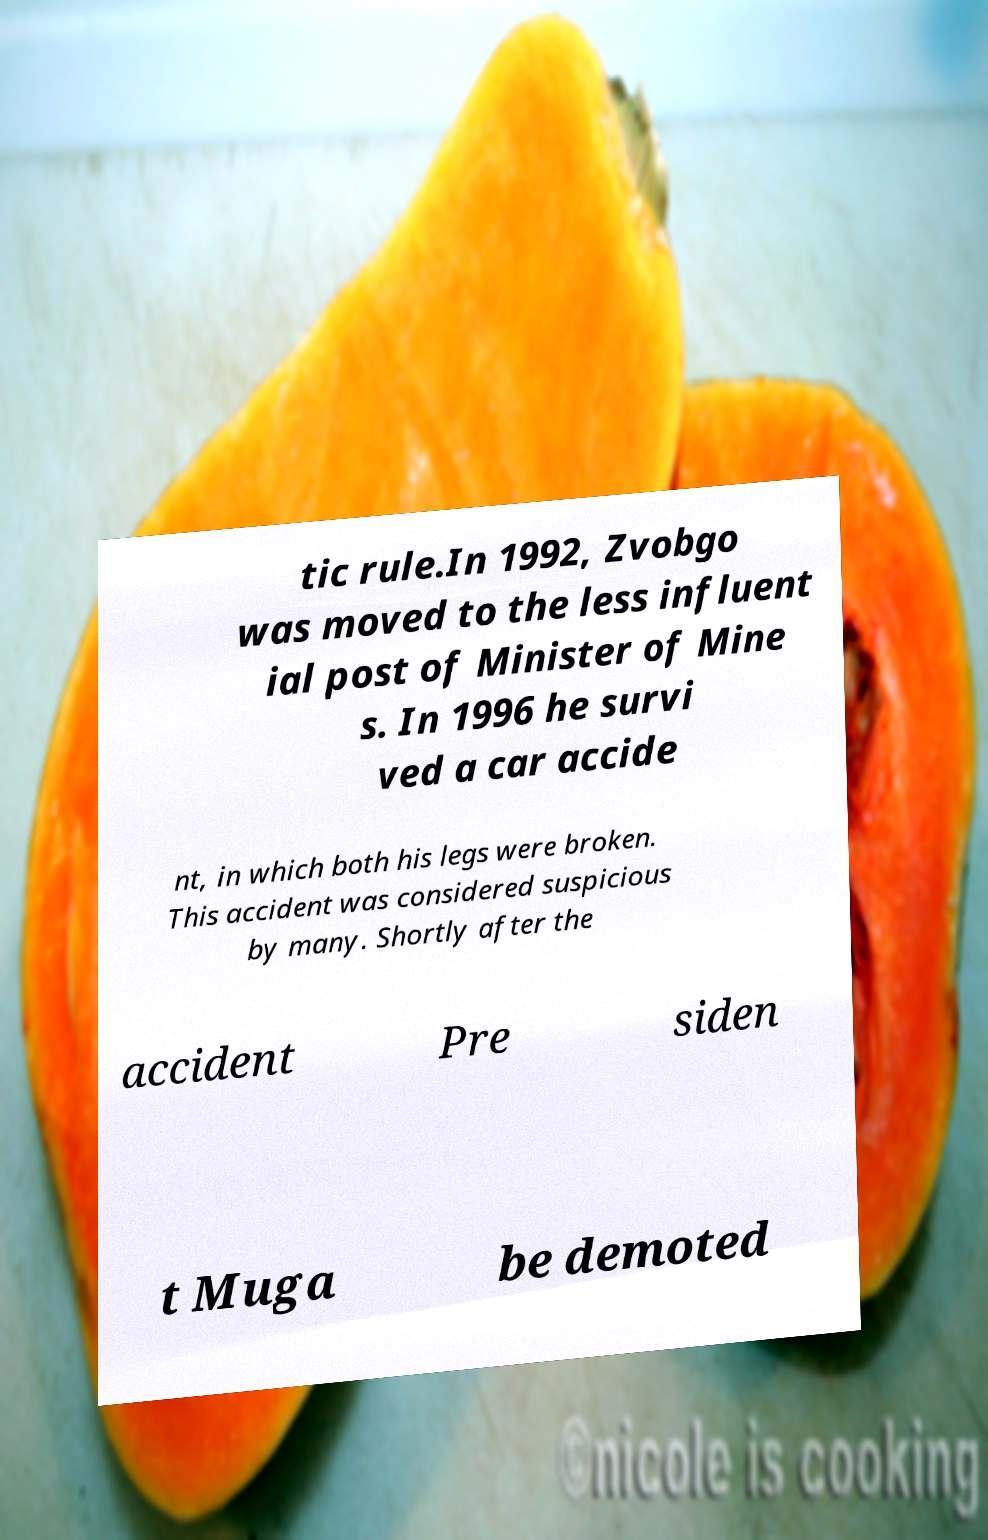Please identify and transcribe the text found in this image. tic rule.In 1992, Zvobgo was moved to the less influent ial post of Minister of Mine s. In 1996 he survi ved a car accide nt, in which both his legs were broken. This accident was considered suspicious by many. Shortly after the accident Pre siden t Muga be demoted 